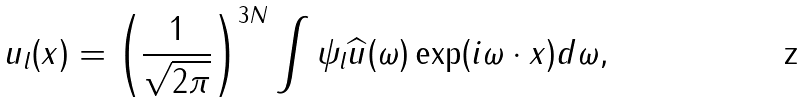Convert formula to latex. <formula><loc_0><loc_0><loc_500><loc_500>u _ { l } ( x ) = \left ( \frac { 1 } { \sqrt { 2 \pi } } \right ) ^ { 3 N } \int \psi _ { l } \widehat { u } ( \omega ) \exp ( { i \omega \cdot x } ) d \omega ,</formula> 